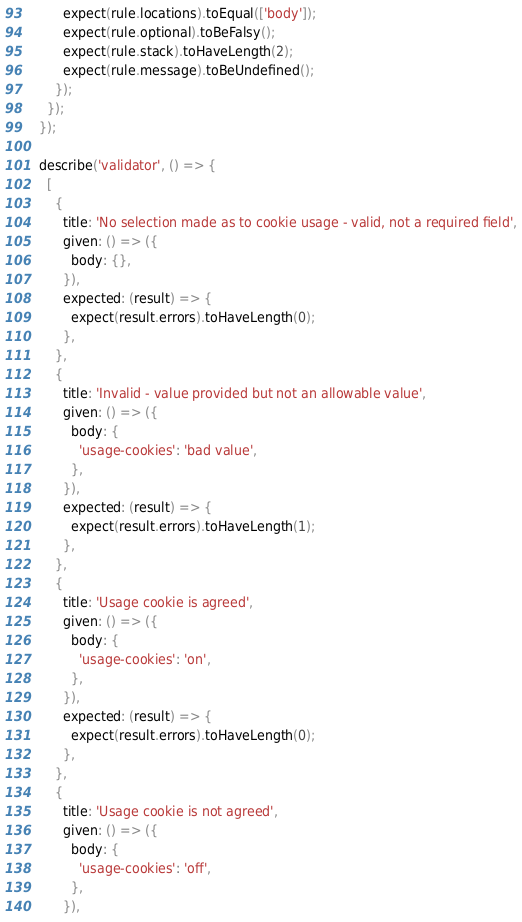Convert code to text. <code><loc_0><loc_0><loc_500><loc_500><_JavaScript_>        expect(rule.locations).toEqual(['body']);
        expect(rule.optional).toBeFalsy();
        expect(rule.stack).toHaveLength(2);
        expect(rule.message).toBeUndefined();
      });
    });
  });

  describe('validator', () => {
    [
      {
        title: 'No selection made as to cookie usage - valid, not a required field',
        given: () => ({
          body: {},
        }),
        expected: (result) => {
          expect(result.errors).toHaveLength(0);
        },
      },
      {
        title: 'Invalid - value provided but not an allowable value',
        given: () => ({
          body: {
            'usage-cookies': 'bad value',
          },
        }),
        expected: (result) => {
          expect(result.errors).toHaveLength(1);
        },
      },
      {
        title: 'Usage cookie is agreed',
        given: () => ({
          body: {
            'usage-cookies': 'on',
          },
        }),
        expected: (result) => {
          expect(result.errors).toHaveLength(0);
        },
      },
      {
        title: 'Usage cookie is not agreed',
        given: () => ({
          body: {
            'usage-cookies': 'off',
          },
        }),</code> 